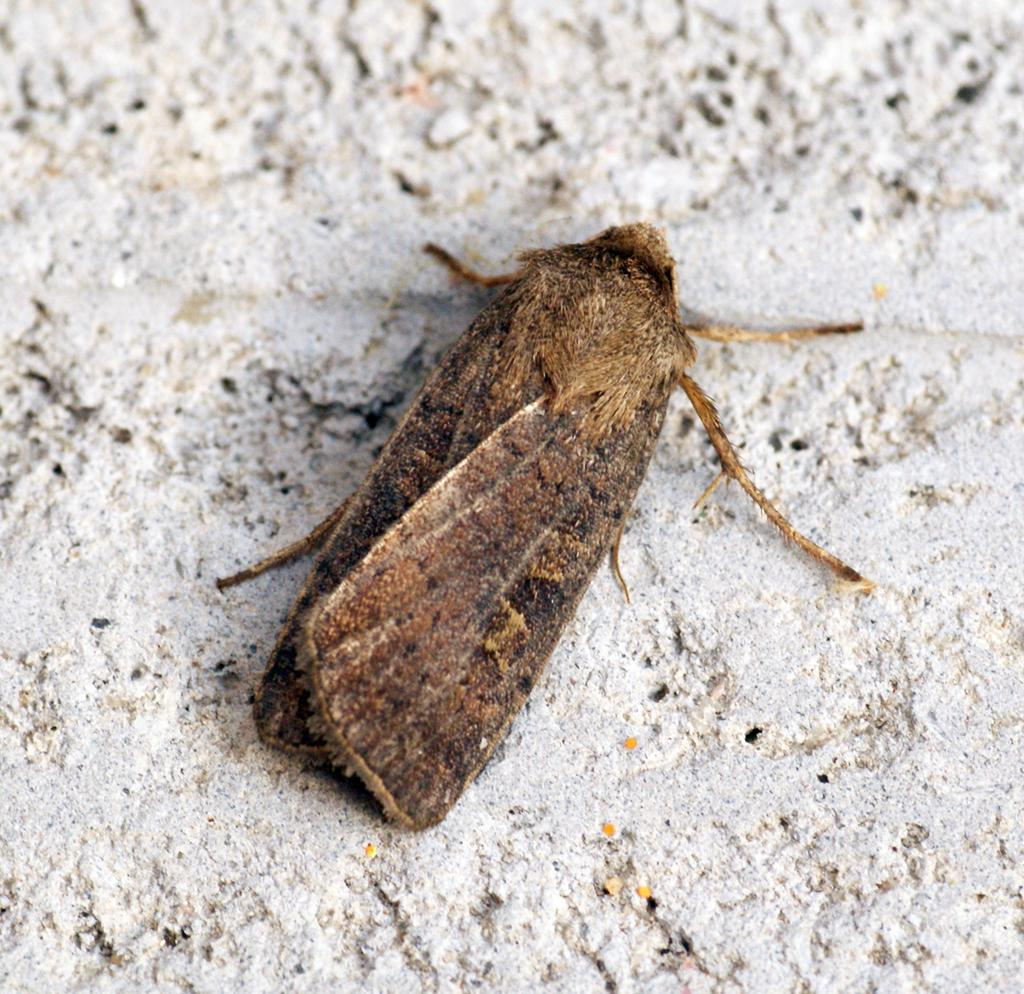What type of creature can be seen in the image? There is an insect in the image. How many boats are visible in the image? There are no boats present in the image; it features an insect. What type of lizard can be seen interacting with the insect in the image? There is no lizard present in the image; only the insect is visible. 